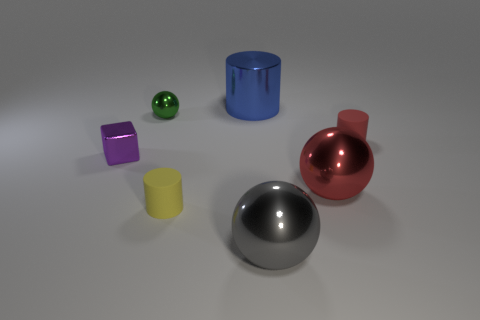Subtract all yellow rubber cylinders. How many cylinders are left? 2 Subtract 1 spheres. How many spheres are left? 2 Add 2 tiny gray rubber cubes. How many objects exist? 9 Subtract all purple cylinders. Subtract all green blocks. How many cylinders are left? 3 Subtract all cylinders. How many objects are left? 4 Subtract all small cyan matte spheres. Subtract all tiny red objects. How many objects are left? 6 Add 6 yellow matte cylinders. How many yellow matte cylinders are left? 7 Add 5 brown objects. How many brown objects exist? 5 Subtract 0 red blocks. How many objects are left? 7 